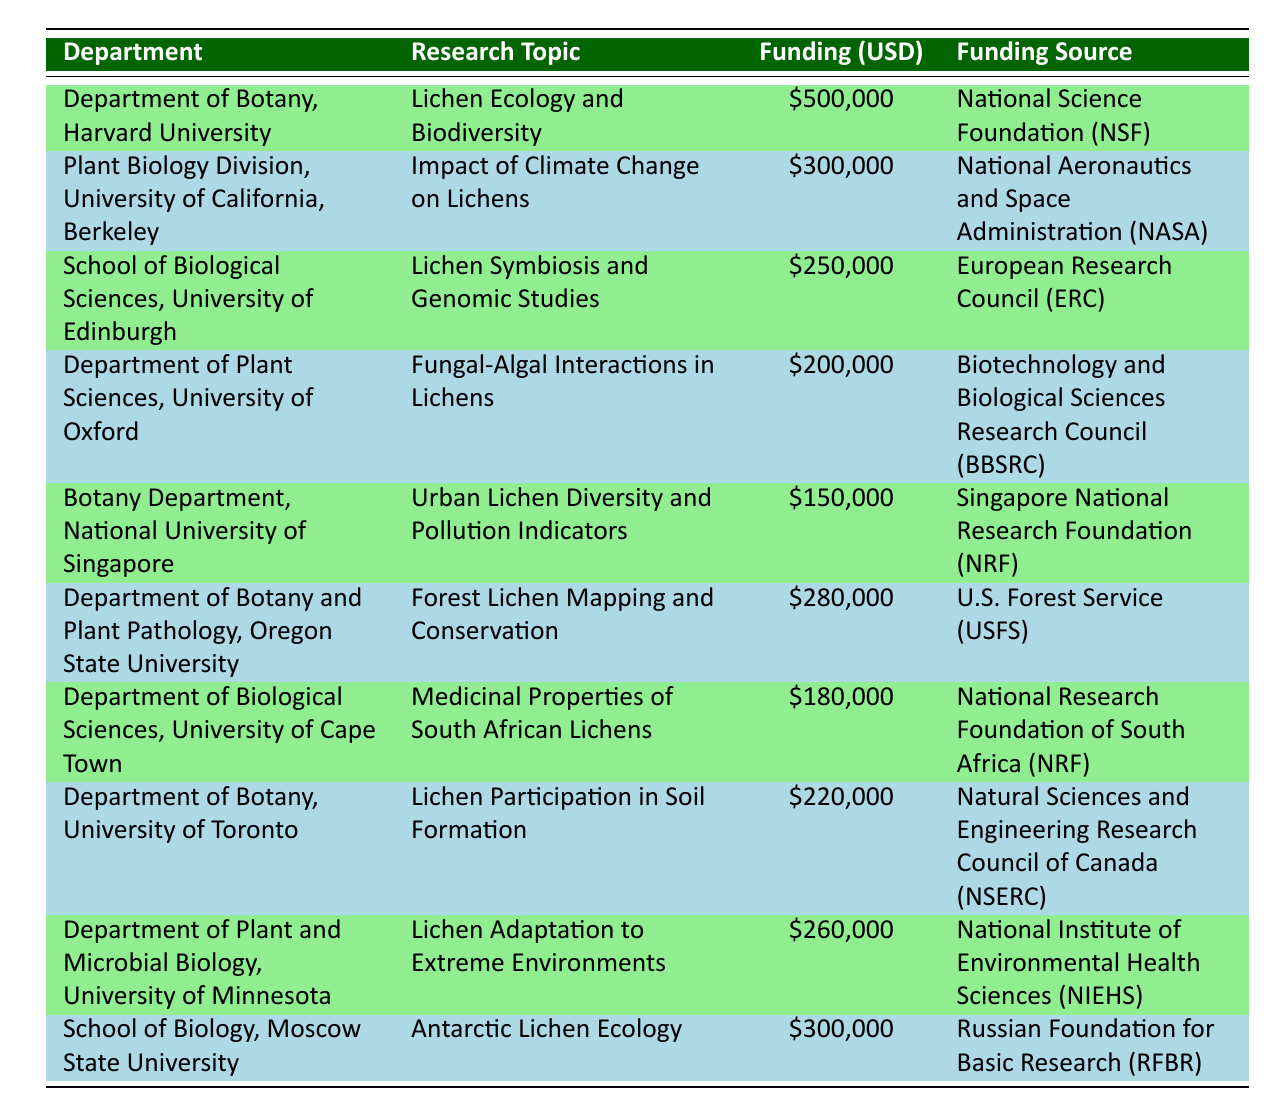What is the highest funding received by a department? The department that received the highest funding is the Department of Botany, Harvard University, which received 500,000 USD. This is directly shown in the table where the Department is listed first with the corresponding funding amount.
Answer: 500,000 USD Which department focuses on the environmental impacts of lichens? The Plant Biology Division, University of California, Berkeley focuses on the impact of climate change on lichens, as indicated in the "Research Topic" column of the table.
Answer: Plant Biology Division, University of California, Berkeley What is the total funding received by all departments listed in the table? To calculate total funding, we sum all the funding amounts: 500,000 + 300,000 + 250,000 + 200,000 + 150,000 + 280,000 + 180,000 + 220,000 + 260,000 + 300,000 = 2,840,000 USD. Therefore, the total funding received by all departments is 2,840,000 USD.
Answer: 2,840,000 USD Is the funding from the National Aeronautics and Space Administration higher than that from the Singapore National Research Foundation? The funding from NASA (300,000 USD) is higher than the funding from the Singapore National Research Foundation (150,000 USD). This can be confirmed by directly comparing the amounts given in the table under the "Funding Received USD" for each department associated with these funding sources.
Answer: Yes Which two departments received a total of more than 500,000 USD? The Department of Botany, Harvard University (500,000 USD) and the School of Biology, Moscow State University (300,000 USD) received a total of 800,000 USD. 500,000 + 300,000 = 800,000 which exceeds 500,000 USD.
Answer: Department of Botany, Harvard University & School of Biology, Moscow State University 